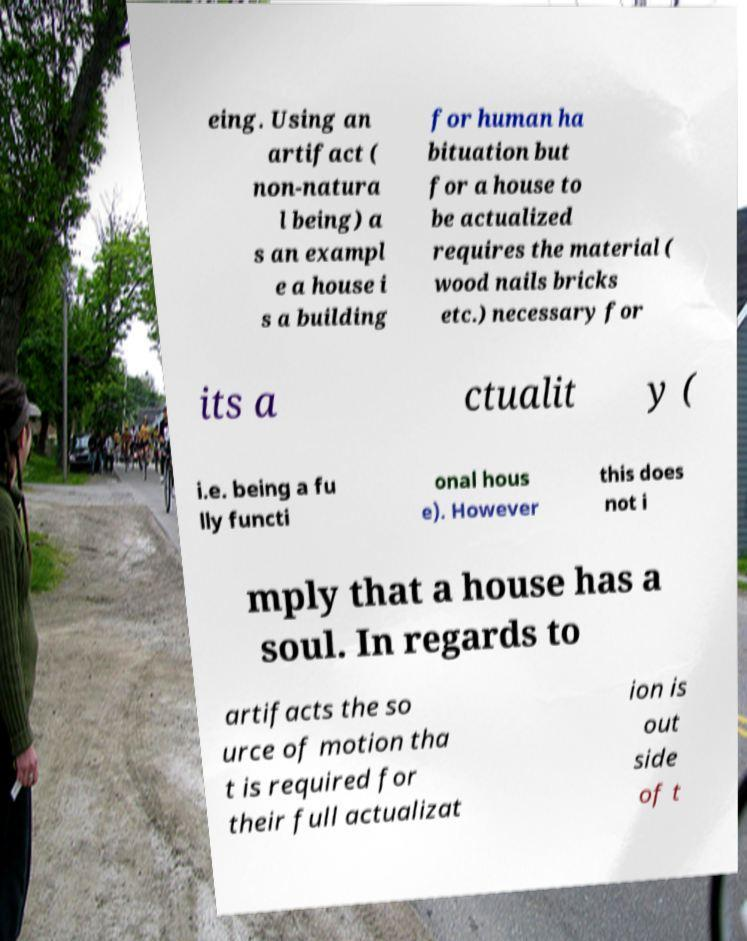Can you accurately transcribe the text from the provided image for me? eing. Using an artifact ( non-natura l being) a s an exampl e a house i s a building for human ha bituation but for a house to be actualized requires the material ( wood nails bricks etc.) necessary for its a ctualit y ( i.e. being a fu lly functi onal hous e). However this does not i mply that a house has a soul. In regards to artifacts the so urce of motion tha t is required for their full actualizat ion is out side of t 